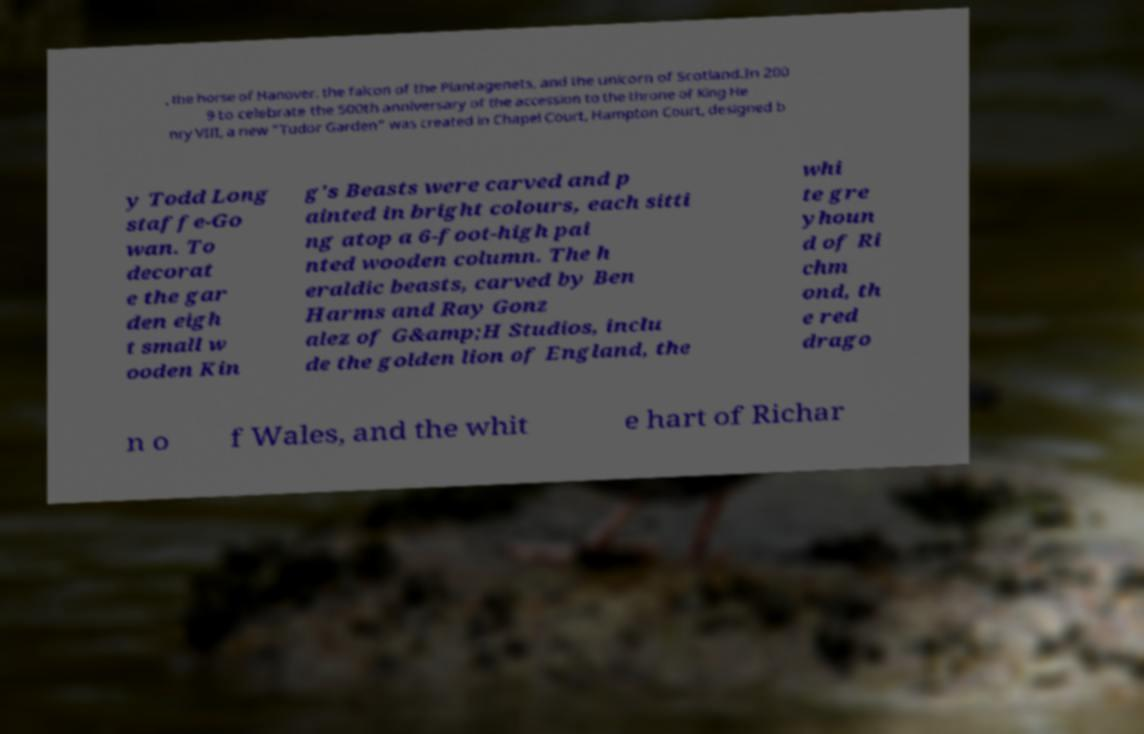For documentation purposes, I need the text within this image transcribed. Could you provide that? , the horse of Hanover, the falcon of the Plantagenets, and the unicorn of Scotland.In 200 9 to celebrate the 500th anniversary of the accession to the throne of King He nry VIII, a new "Tudor Garden" was created in Chapel Court, Hampton Court, designed b y Todd Long staffe-Go wan. To decorat e the gar den eigh t small w ooden Kin g's Beasts were carved and p ainted in bright colours, each sitti ng atop a 6-foot-high pai nted wooden column. The h eraldic beasts, carved by Ben Harms and Ray Gonz alez of G&amp;H Studios, inclu de the golden lion of England, the whi te gre yhoun d of Ri chm ond, th e red drago n o f Wales, and the whit e hart of Richar 